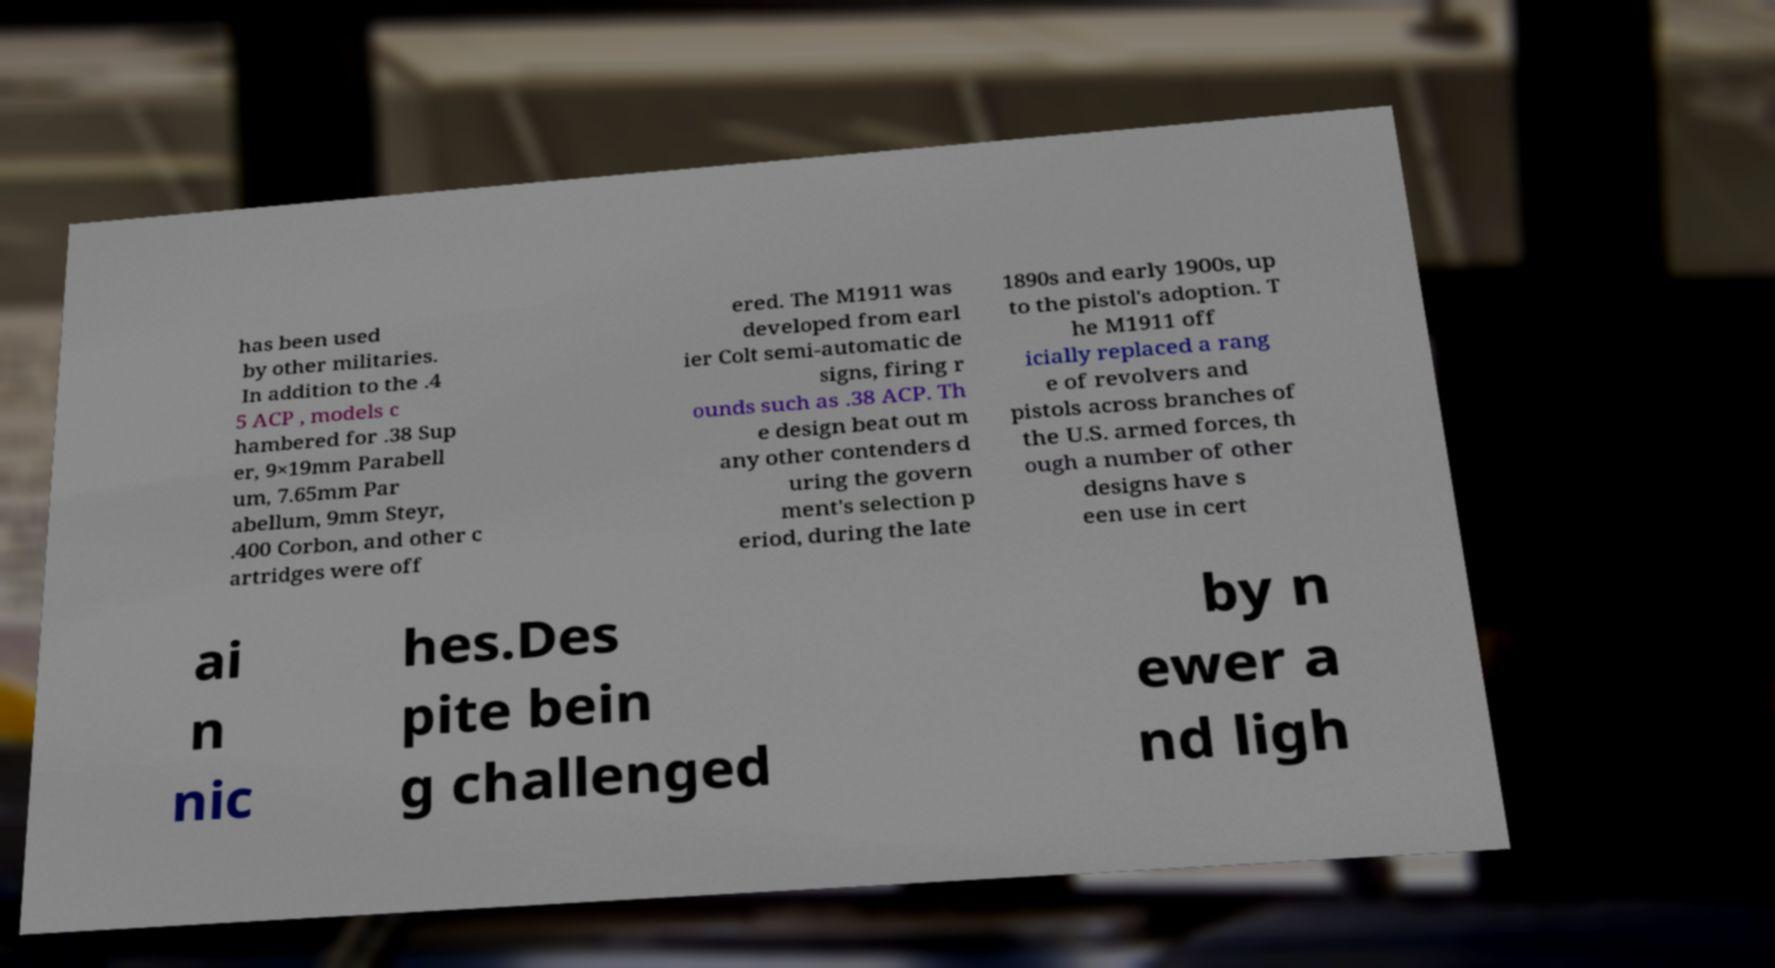Please read and relay the text visible in this image. What does it say? has been used by other militaries. In addition to the .4 5 ACP , models c hambered for .38 Sup er, 9×19mm Parabell um, 7.65mm Par abellum, 9mm Steyr, .400 Corbon, and other c artridges were off ered. The M1911 was developed from earl ier Colt semi-automatic de signs, firing r ounds such as .38 ACP. Th e design beat out m any other contenders d uring the govern ment's selection p eriod, during the late 1890s and early 1900s, up to the pistol's adoption. T he M1911 off icially replaced a rang e of revolvers and pistols across branches of the U.S. armed forces, th ough a number of other designs have s een use in cert ai n nic hes.Des pite bein g challenged by n ewer a nd ligh 